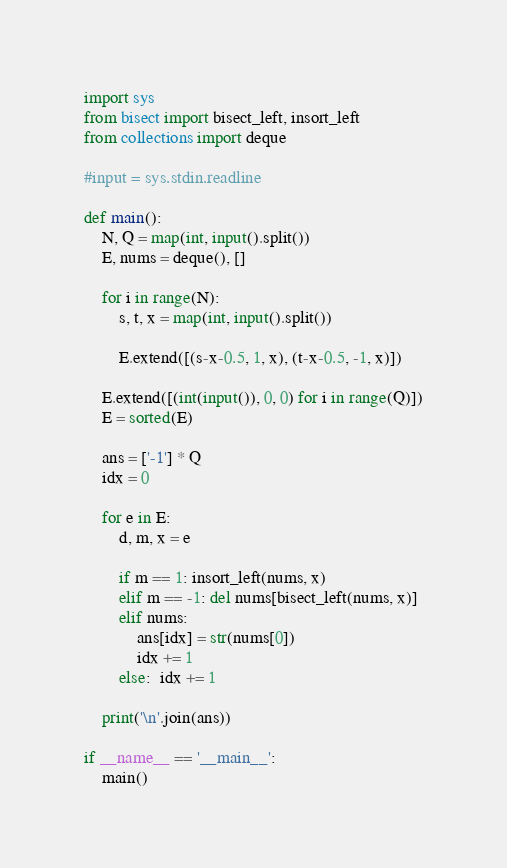<code> <loc_0><loc_0><loc_500><loc_500><_Python_>import sys
from bisect import bisect_left, insort_left
from collections import deque

#input = sys.stdin.readline

def main():
    N, Q = map(int, input().split())
    E, nums = deque(), []
    
    for i in range(N):
        s, t, x = map(int, input().split())
        
        E.extend([(s-x-0.5, 1, x), (t-x-0.5, -1, x)])
        
    E.extend([(int(input()), 0, 0) for i in range(Q)])
    E = sorted(E)
    
    ans = ['-1'] * Q
    idx = 0
    
    for e in E:
        d, m, x = e
        
        if m == 1: insort_left(nums, x)
        elif m == -1: del nums[bisect_left(nums, x)]
        elif nums: 
            ans[idx] = str(nums[0])
            idx += 1
        else:  idx += 1
        
    print('\n'.join(ans))
    
if __name__ == '__main__':
    main()</code> 